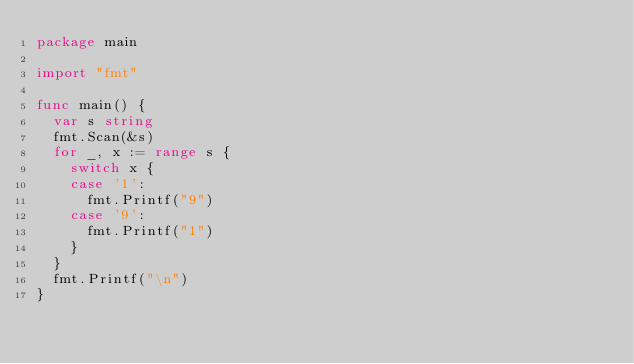<code> <loc_0><loc_0><loc_500><loc_500><_Go_>package main

import "fmt"

func main() {
	var s string
	fmt.Scan(&s)
	for _, x := range s {
		switch x {
		case '1':
			fmt.Printf("9")
		case '9':
			fmt.Printf("1")
		}
	}
	fmt.Printf("\n")
}
</code> 